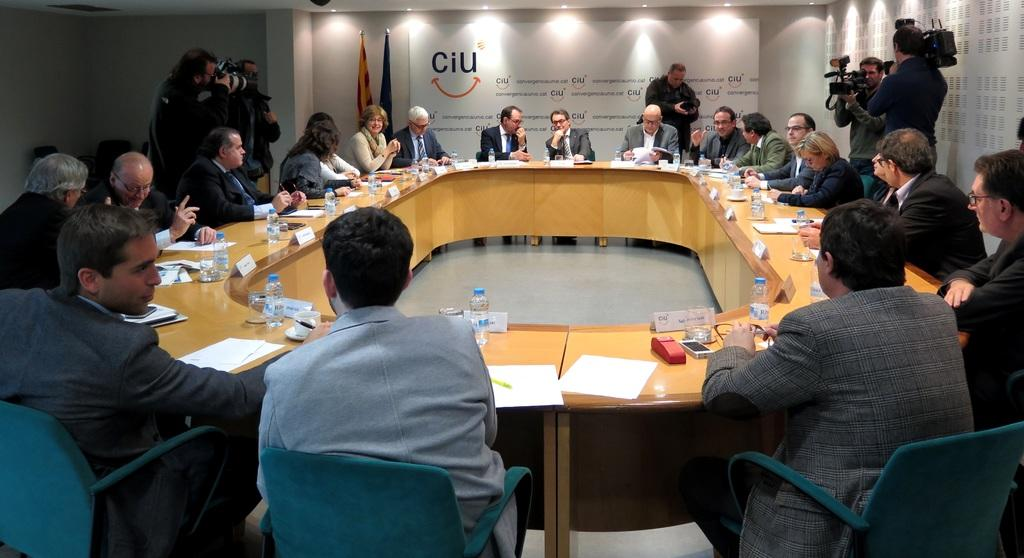How many people are in the image? There is a group of people in the image. How are the people arranged in the image? The people are sitting in a circular manner. What are the people doing in the image? The people are engaged in a discussion. What type of chalk is being used by the people in the image? There is no chalk present in the image; the people are engaged in a discussion while sitting in a circular manner. 